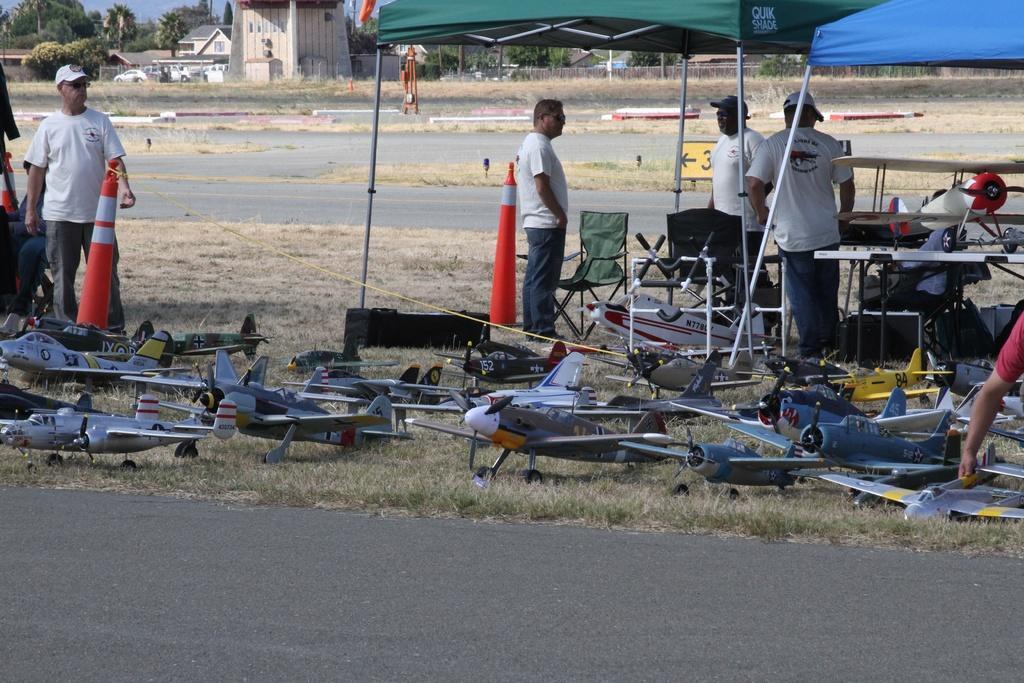Can you describe this image briefly? In the image we can see there are people standing, wearing clothes and some of them are wearing caps. Here we can see flying jets, road and grass. Here we can see the tents, vehicles and houses. We can even see there are trees and the sky. 